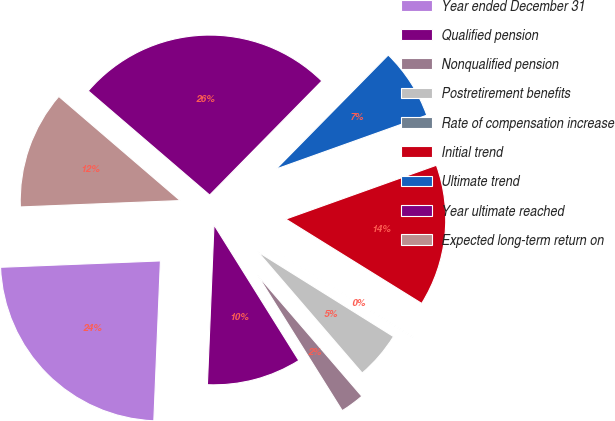Convert chart to OTSL. <chart><loc_0><loc_0><loc_500><loc_500><pie_chart><fcel>Year ended December 31<fcel>Qualified pension<fcel>Nonqualified pension<fcel>Postretirement benefits<fcel>Rate of compensation increase<fcel>Initial trend<fcel>Ultimate trend<fcel>Year ultimate reached<fcel>Expected long-term return on<nl><fcel>23.71%<fcel>9.55%<fcel>2.42%<fcel>4.8%<fcel>0.05%<fcel>14.3%<fcel>7.17%<fcel>26.08%<fcel>11.92%<nl></chart> 